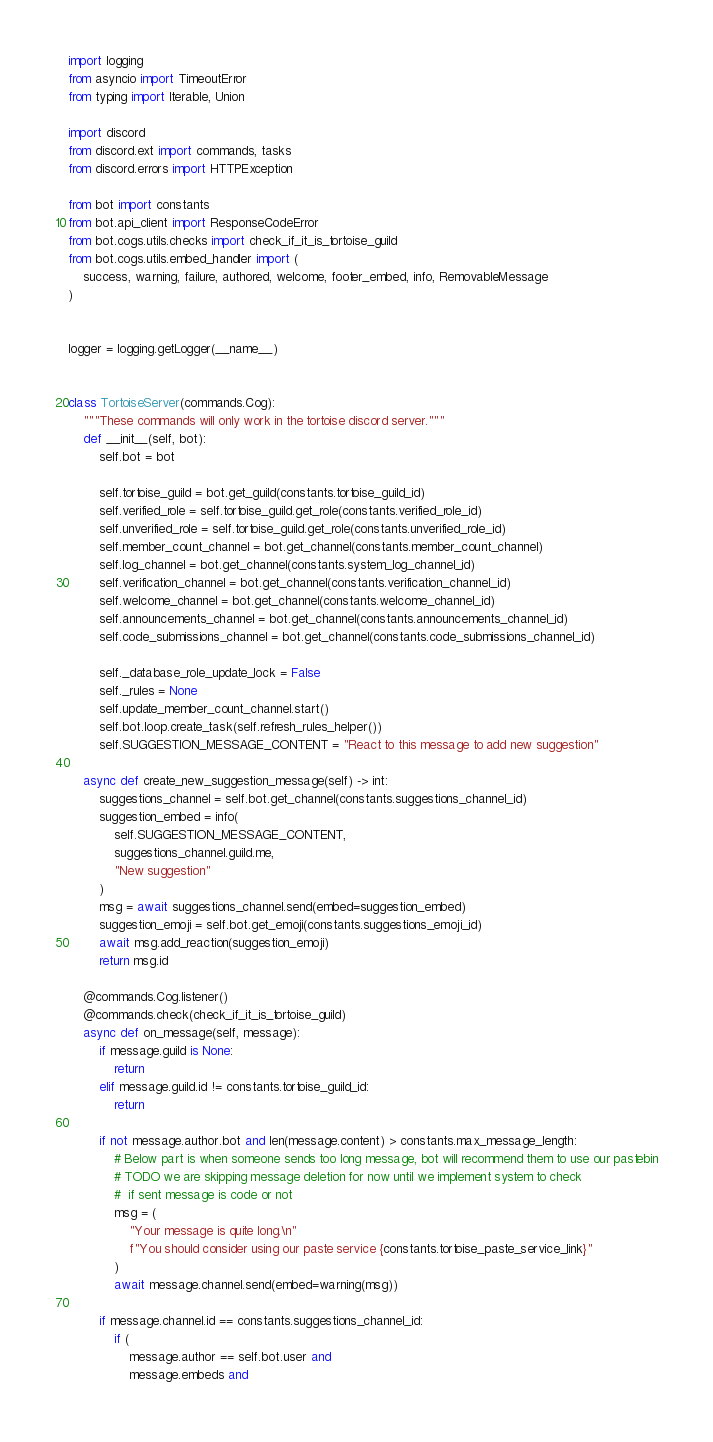<code> <loc_0><loc_0><loc_500><loc_500><_Python_>import logging
from asyncio import TimeoutError
from typing import Iterable, Union

import discord
from discord.ext import commands, tasks
from discord.errors import HTTPException

from bot import constants
from bot.api_client import ResponseCodeError
from bot.cogs.utils.checks import check_if_it_is_tortoise_guild
from bot.cogs.utils.embed_handler import (
    success, warning, failure, authored, welcome, footer_embed, info, RemovableMessage
)


logger = logging.getLogger(__name__)


class TortoiseServer(commands.Cog):
    """These commands will only work in the tortoise discord server."""
    def __init__(self, bot):
        self.bot = bot

        self.tortoise_guild = bot.get_guild(constants.tortoise_guild_id)
        self.verified_role = self.tortoise_guild.get_role(constants.verified_role_id)
        self.unverified_role = self.tortoise_guild.get_role(constants.unverified_role_id)
        self.member_count_channel = bot.get_channel(constants.member_count_channel)
        self.log_channel = bot.get_channel(constants.system_log_channel_id)
        self.verification_channel = bot.get_channel(constants.verification_channel_id)
        self.welcome_channel = bot.get_channel(constants.welcome_channel_id)
        self.announcements_channel = bot.get_channel(constants.announcements_channel_id)
        self.code_submissions_channel = bot.get_channel(constants.code_submissions_channel_id)

        self._database_role_update_lock = False
        self._rules = None
        self.update_member_count_channel.start()
        self.bot.loop.create_task(self.refresh_rules_helper())
        self.SUGGESTION_MESSAGE_CONTENT = "React to this message to add new suggestion"

    async def create_new_suggestion_message(self) -> int:
        suggestions_channel = self.bot.get_channel(constants.suggestions_channel_id)
        suggestion_embed = info(
            self.SUGGESTION_MESSAGE_CONTENT,
            suggestions_channel.guild.me,
            "New suggestion"
        )
        msg = await suggestions_channel.send(embed=suggestion_embed)
        suggestion_emoji = self.bot.get_emoji(constants.suggestions_emoji_id)
        await msg.add_reaction(suggestion_emoji)
        return msg.id

    @commands.Cog.listener()
    @commands.check(check_if_it_is_tortoise_guild)
    async def on_message(self, message):
        if message.guild is None:
            return
        elif message.guild.id != constants.tortoise_guild_id:
            return

        if not message.author.bot and len(message.content) > constants.max_message_length:
            # Below part is when someone sends too long message, bot will recommend them to use our pastebin
            # TODO we are skipping message deletion for now until we implement system to check
            #  if sent message is code or not
            msg = (
                "Your message is quite long.\n"
                f"You should consider using our paste service {constants.tortoise_paste_service_link}"
            )
            await message.channel.send(embed=warning(msg))

        if message.channel.id == constants.suggestions_channel_id:
            if (
                message.author == self.bot.user and
                message.embeds and</code> 